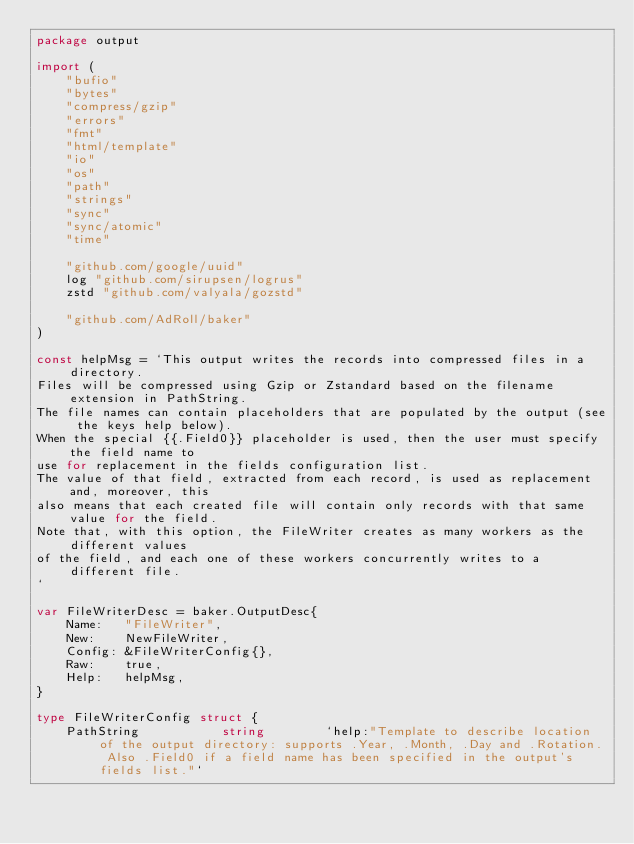Convert code to text. <code><loc_0><loc_0><loc_500><loc_500><_Go_>package output

import (
	"bufio"
	"bytes"
	"compress/gzip"
	"errors"
	"fmt"
	"html/template"
	"io"
	"os"
	"path"
	"strings"
	"sync"
	"sync/atomic"
	"time"

	"github.com/google/uuid"
	log "github.com/sirupsen/logrus"
	zstd "github.com/valyala/gozstd"

	"github.com/AdRoll/baker"
)

const helpMsg = `This output writes the records into compressed files in a directory.
Files will be compressed using Gzip or Zstandard based on the filename extension in PathString.
The file names can contain placeholders that are populated by the output (see the keys help below).
When the special {{.Field0}} placeholder is used, then the user must specify the field name to
use for replacement in the fields configuration list.
The value of that field, extracted from each record, is used as replacement and, moreover, this
also means that each created file will contain only records with that same value for the field.
Note that, with this option, the FileWriter creates as many workers as the different values
of the field, and each one of these workers concurrently writes to a different file.
`

var FileWriterDesc = baker.OutputDesc{
	Name:   "FileWriter",
	New:    NewFileWriter,
	Config: &FileWriterConfig{},
	Raw:    true,
	Help:   helpMsg,
}

type FileWriterConfig struct {
	PathString           string        `help:"Template to describe location of the output directory: supports .Year, .Month, .Day and .Rotation. Also .Field0 if a field name has been specified in the output's fields list."`</code> 